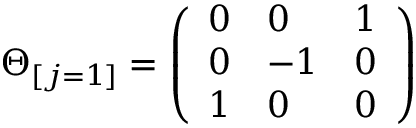Convert formula to latex. <formula><loc_0><loc_0><loc_500><loc_500>\Theta _ { [ j = 1 ] } = \left ( \begin{array} { l l l } { 0 } & { 0 } & { 1 } \\ { 0 } & { - 1 } & { 0 } \\ { 1 } & { 0 } & { 0 } \end{array} \right )</formula> 